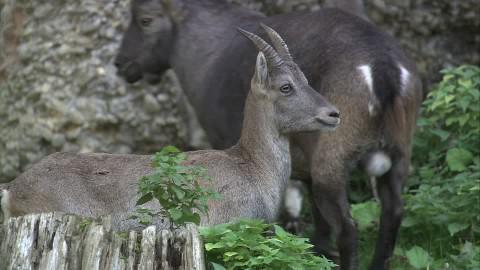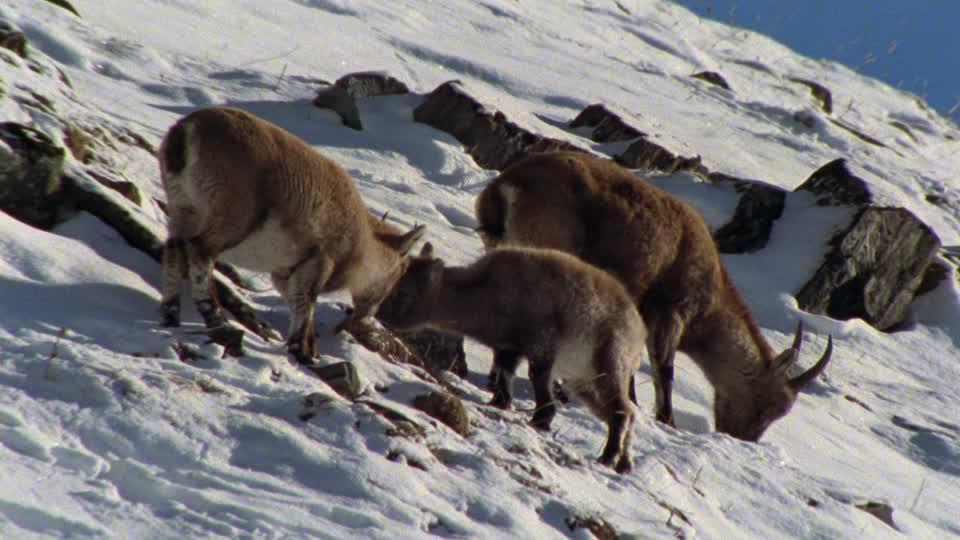The first image is the image on the left, the second image is the image on the right. For the images shown, is this caption "There is snow visible." true? Answer yes or no. Yes. 